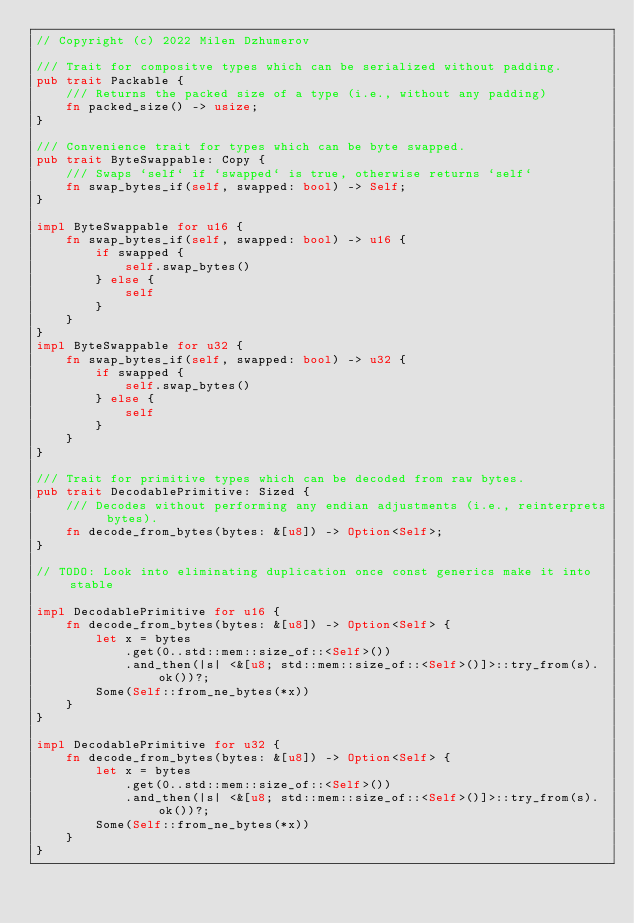<code> <loc_0><loc_0><loc_500><loc_500><_Rust_>// Copyright (c) 2022 Milen Dzhumerov

/// Trait for compositve types which can be serialized without padding.
pub trait Packable {
    /// Returns the packed size of a type (i.e., without any padding)
    fn packed_size() -> usize;
}

/// Convenience trait for types which can be byte swapped.
pub trait ByteSwappable: Copy {
    /// Swaps `self` if `swapped` is true, otherwise returns `self`
    fn swap_bytes_if(self, swapped: bool) -> Self;
}

impl ByteSwappable for u16 {
    fn swap_bytes_if(self, swapped: bool) -> u16 {
        if swapped {
            self.swap_bytes()
        } else {
            self
        }
    }
}
impl ByteSwappable for u32 {
    fn swap_bytes_if(self, swapped: bool) -> u32 {
        if swapped {
            self.swap_bytes()
        } else {
            self
        }
    }
}

/// Trait for primitive types which can be decoded from raw bytes.
pub trait DecodablePrimitive: Sized {
    /// Decodes without performing any endian adjustments (i.e., reinterprets bytes).
    fn decode_from_bytes(bytes: &[u8]) -> Option<Self>;
}

// TODO: Look into eliminating duplication once const generics make it into stable

impl DecodablePrimitive for u16 {
    fn decode_from_bytes(bytes: &[u8]) -> Option<Self> {
        let x = bytes
            .get(0..std::mem::size_of::<Self>())
            .and_then(|s| <&[u8; std::mem::size_of::<Self>()]>::try_from(s).ok())?;
        Some(Self::from_ne_bytes(*x))
    }
}

impl DecodablePrimitive for u32 {
    fn decode_from_bytes(bytes: &[u8]) -> Option<Self> {
        let x = bytes
            .get(0..std::mem::size_of::<Self>())
            .and_then(|s| <&[u8; std::mem::size_of::<Self>()]>::try_from(s).ok())?;
        Some(Self::from_ne_bytes(*x))
    }
}
</code> 